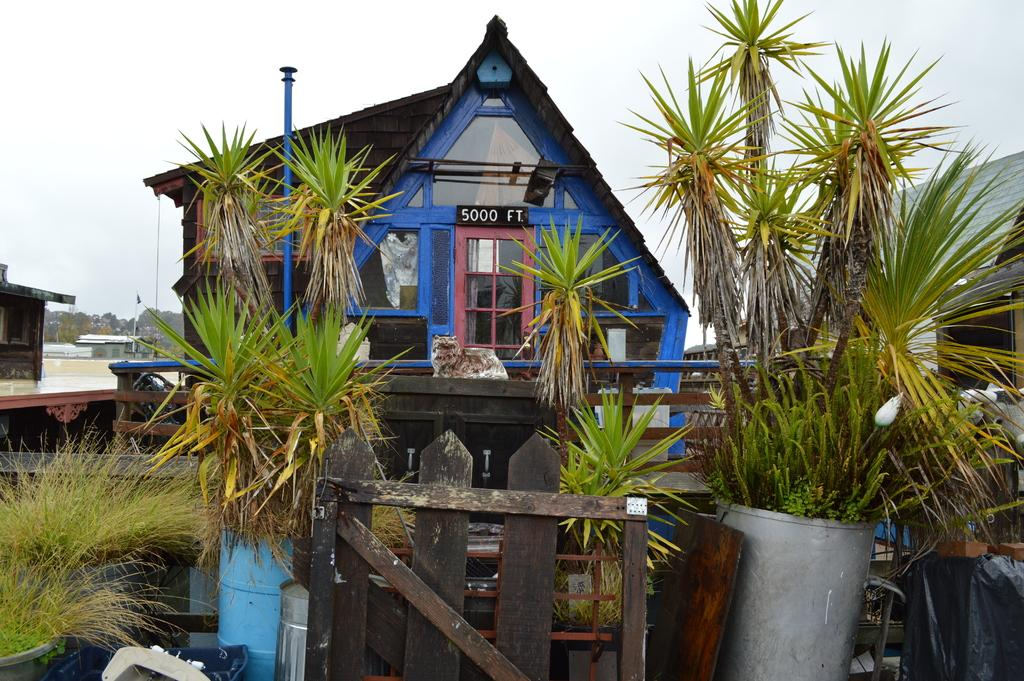What type of structures can be seen in the image? There are houses in the image. What other elements can be seen in the image besides houses? There are plants, wooden objects, glass, doors, poles, and trees in the image. What is visible in the background of the image? The sky is visible in the background of the image. How does the van navigate through the rainstorm in the image? There is no van or rainstorm present in the image. 